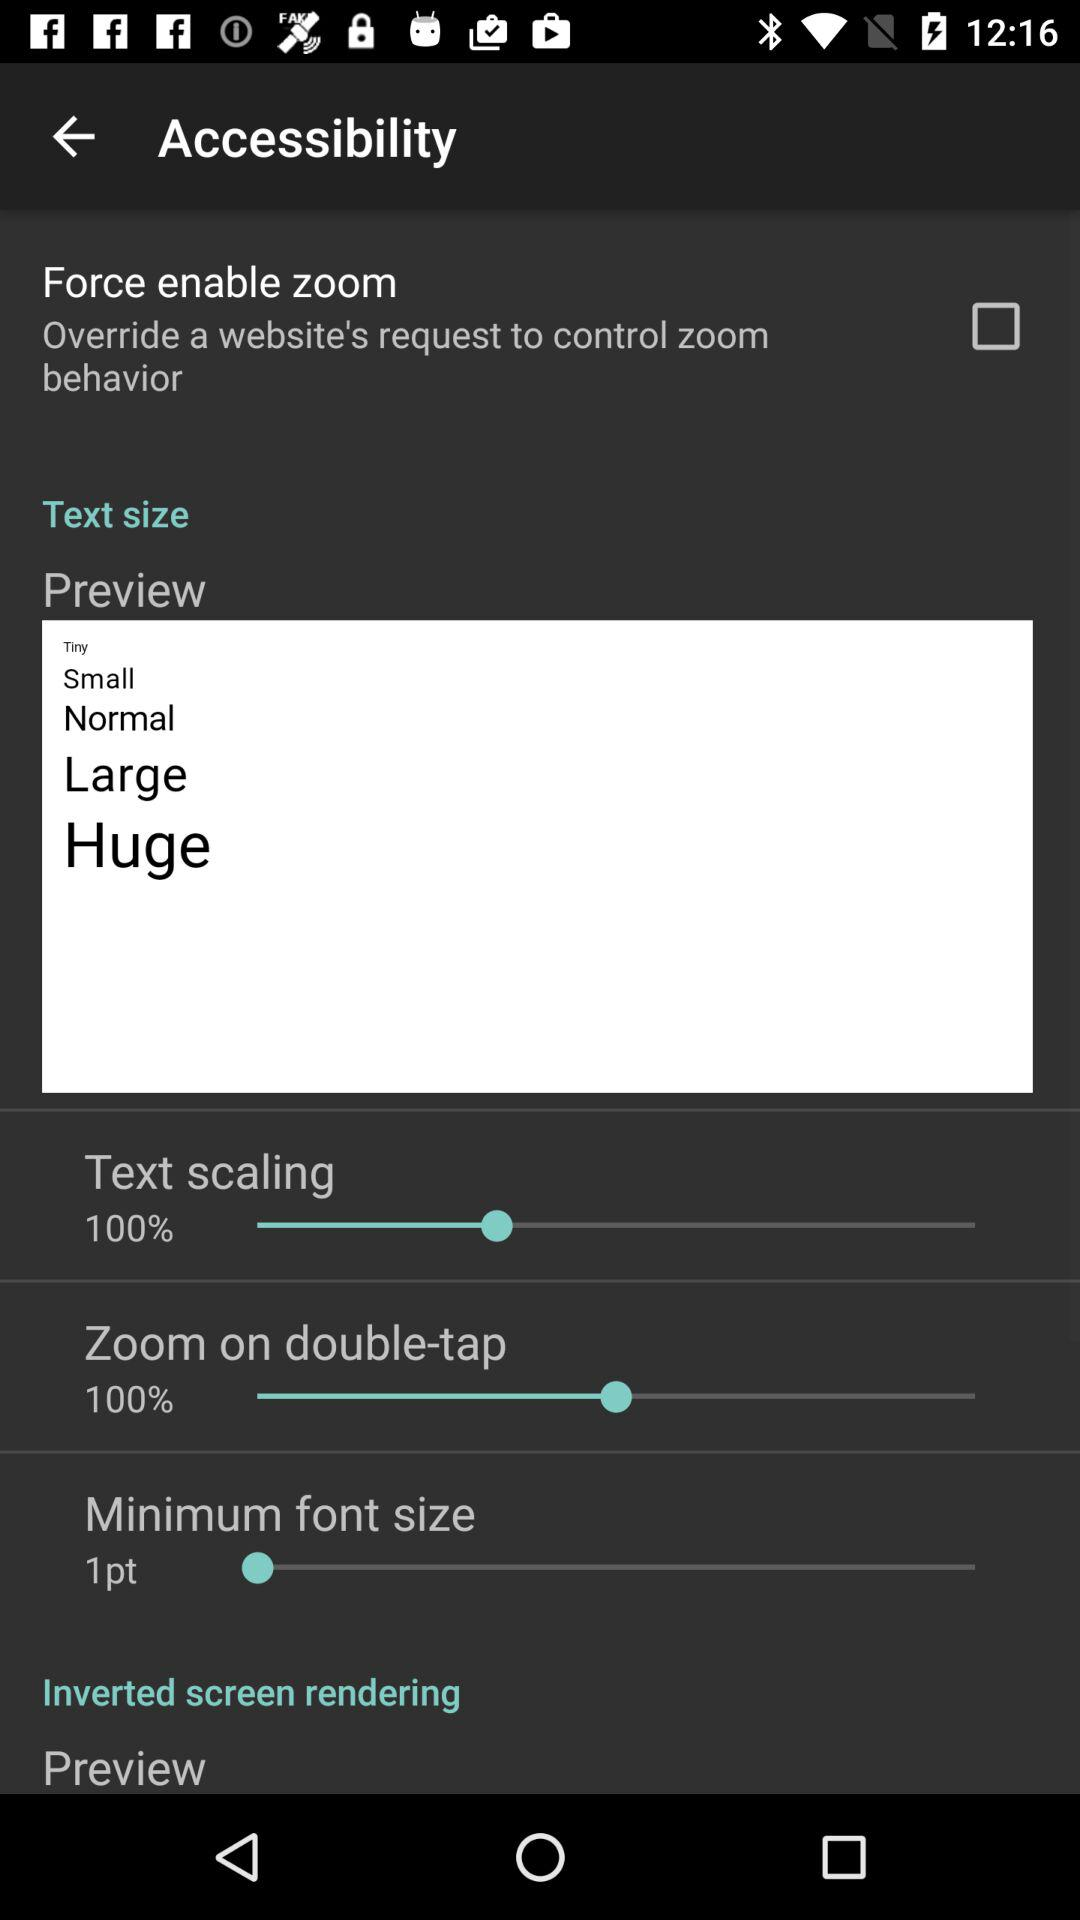What percentage is the minimum font size set to?
Answer the question using a single word or phrase. 1pt 